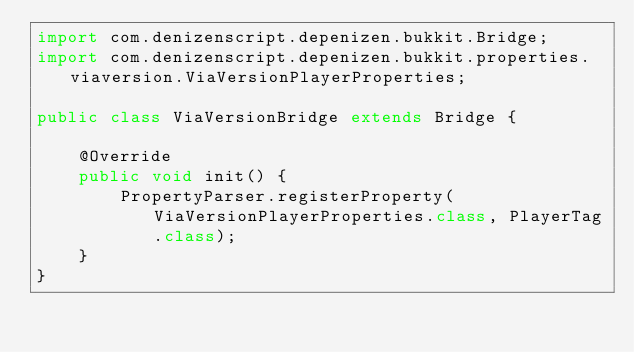<code> <loc_0><loc_0><loc_500><loc_500><_Java_>import com.denizenscript.depenizen.bukkit.Bridge;
import com.denizenscript.depenizen.bukkit.properties.viaversion.ViaVersionPlayerProperties;

public class ViaVersionBridge extends Bridge {

    @Override
    public void init() {
        PropertyParser.registerProperty(ViaVersionPlayerProperties.class, PlayerTag.class);
    }
}
</code> 